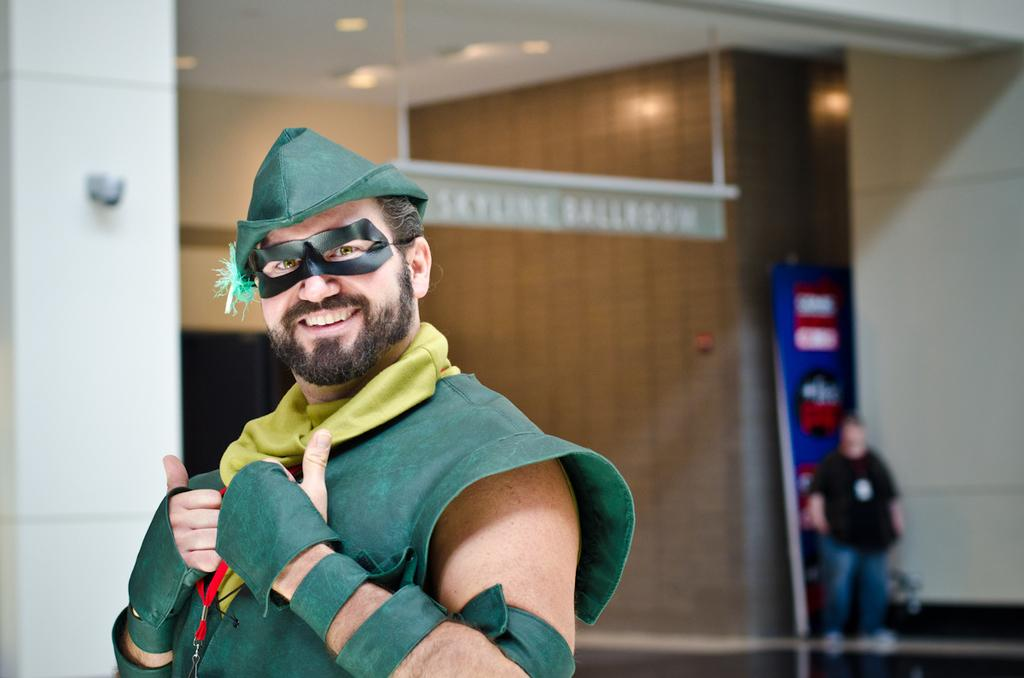What is the main subject of the image? There is a person standing in the image. What is the person wearing? The person is wearing a drama costume. What can be seen in the background of the image? There is a building behind the person. Are there any other people visible in the image? Yes, there is another person behind the building. What type of line can be seen in the image? There is no line present in the image. What kind of clouds are visible in the image? There are no clouds visible in the image. 